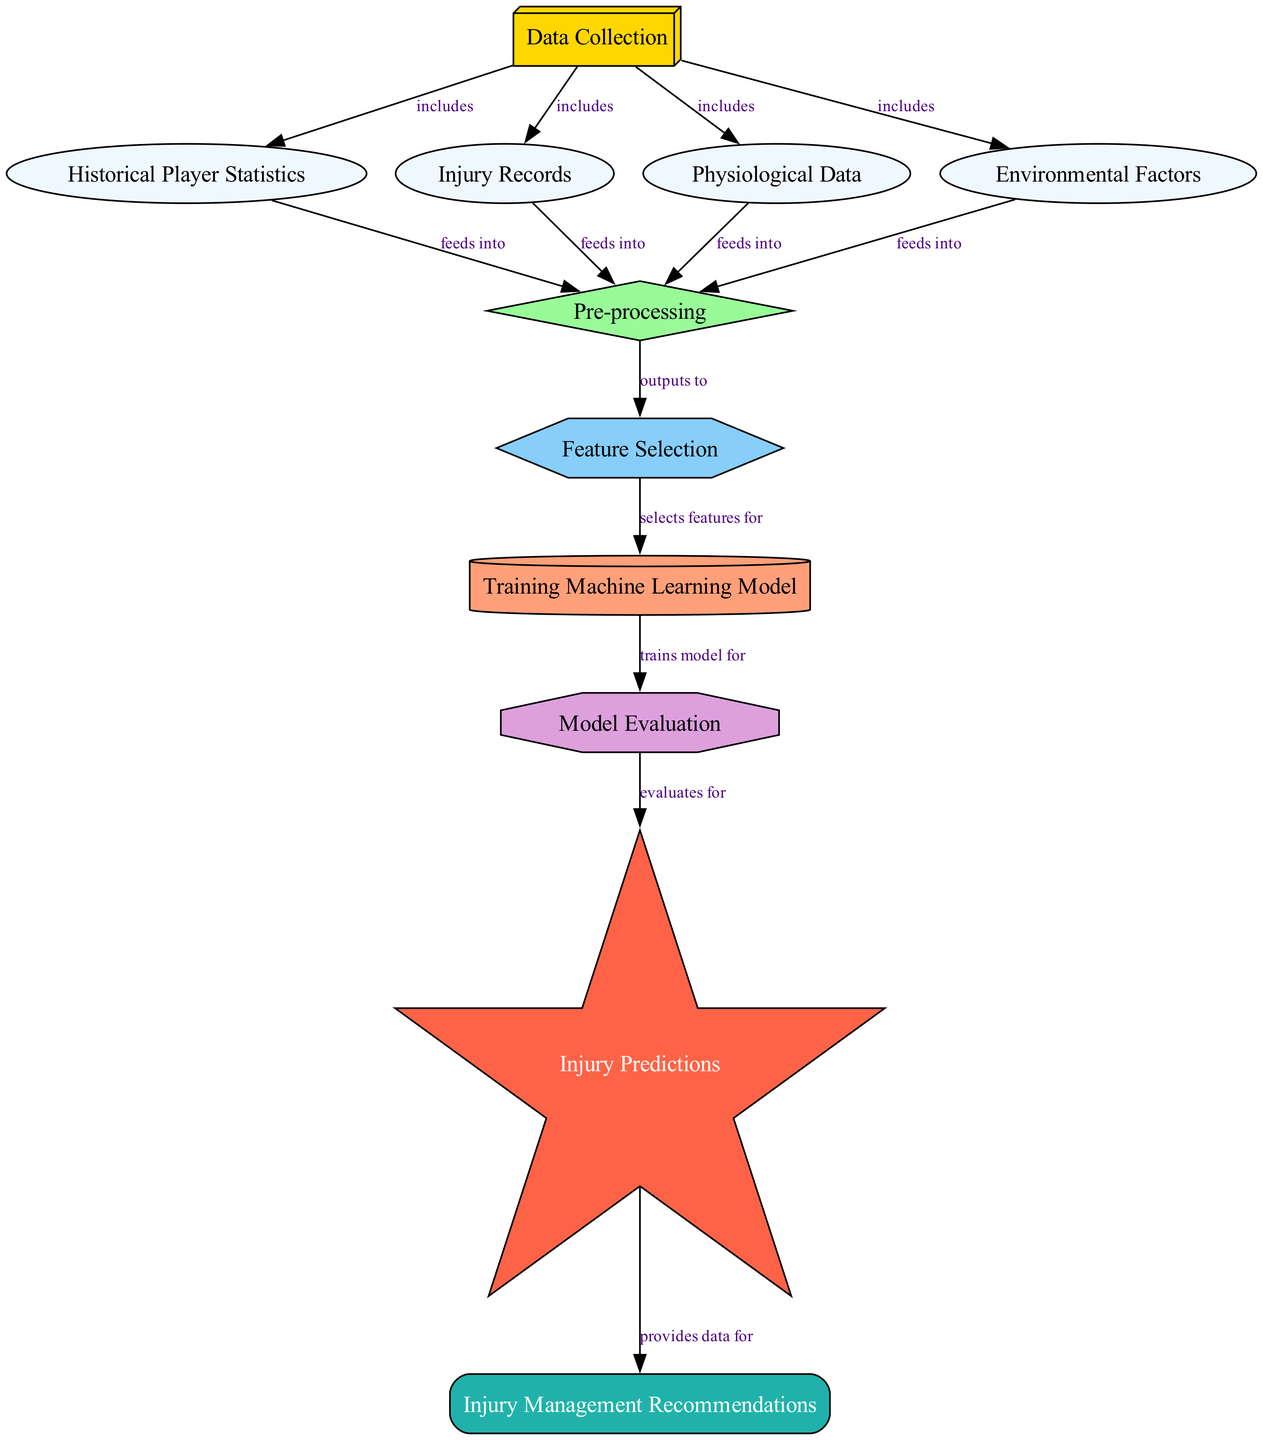What is the total number of nodes in the diagram? By counting the items listed in the "nodes" section of the data, we find there are 11 distinct nodes describing various parts of the player injury prediction and management process.
Answer: 11 Which node is responsible for providing data for injury management recommendations? The edge originating from "Prediction" points to "Management," indicating that the "Prediction" node is responsible for providing data for injury management recommendations.
Answer: Prediction What type of data is collected in the first step? The "Data Collection" node includes "Historical Player Statistics," "Injury Records," "Physiological Data," and "Environmental Factors," specifying the types of data collected at the initial stage.
Answer: Historical Player Statistics, Injury Records, Physiological Data, Environmental Factors After preprocessing, what is the next step? The "Pre-processing" node connects to "Feature Selection," indicating that the next step after preprocessing is selecting relevant features from the collected data.
Answer: Feature Selection How many edges are there connecting the nodes in the diagram? By examining the "edges" section of the data, we find there are 14 connections between the nodes showing how data flows from one step to another in the process.
Answer: 14 Which node is a hexagon shape? In the diagram, the "Feature Selection" node is defined with the shape of a hexagon, which is unique among the other node shapes shown in the diagram.
Answer: Feature Selection What relationship is indicated between "Model Evaluation" and "Prediction"? The edge from "Model Evaluation" to "Prediction" describes a relationship where the model evaluation process evaluates the model's performance to generate injury predictions.
Answer: evaluates for Which node includes environmental factors as part of its data? The "Data Collection" node includes several types of data, and one of them is "Environmental Factors," indicating the importance of these factors in the data collection process.
Answer: Data Collection What is the final outcome of this diagram? The process culminates in the "Management" node, which receives recommendations based on the predictions made during the injury prediction phase, indicating the final outcome of the entire process.
Answer: Management 